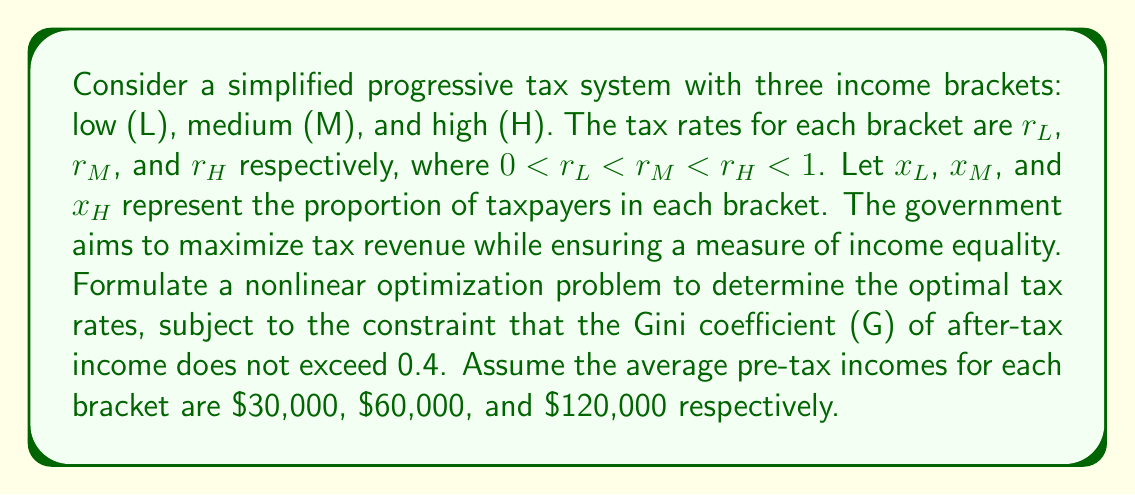Can you answer this question? To solve this problem, we'll follow these steps:

1) First, let's define our objective function. The government wants to maximize tax revenue:

   $$R = 30000r_Lx_L + 60000r_Mx_M + 120000r_Hx_H$$

2) Now, we need to formulate the constraint related to the Gini coefficient. The Gini coefficient for a three-level income distribution can be approximated as:

   $$G = \frac{x_L(y_M-y_L) + x_H(y_H-y_L) + x_M(y_H-y_M)}{2(x_Ly_L + x_My_M + x_Hy_H)}$$

   where $y_L$, $y_M$, and $y_H$ are the after-tax incomes for each bracket.

3) Calculate the after-tax incomes:
   
   $$y_L = 30000(1-r_L)$$
   $$y_M = 60000(1-r_M)$$
   $$y_H = 120000(1-r_H)$$

4) Substitute these into the Gini coefficient formula and set the constraint:

   $$\frac{x_L(60000(1-r_M)-30000(1-r_L)) + x_H(120000(1-r_H)-30000(1-r_L)) + x_M(120000(1-r_H)-60000(1-r_M))}{2(30000x_L(1-r_L) + 60000x_M(1-r_M) + 120000x_H(1-r_H))} \leq 0.4$$

5) We also need to add constraints for the tax rates:

   $$0 < r_L < r_M < r_H < 1$$

6) The proportions of taxpayers must sum to 1:

   $$x_L + x_M + x_H = 1$$

7) Now we can formulate the complete nonlinear optimization problem:

   Maximize:
   $$R = 30000r_Lx_L + 60000r_Mx_M + 120000r_Hx_H$$

   Subject to:
   $$\frac{x_L(60000(1-r_M)-30000(1-r_L)) + x_H(120000(1-r_H)-30000(1-r_L)) + x_M(120000(1-r_H)-60000(1-r_M))}{2(30000x_L(1-r_L) + 60000x_M(1-r_M) + 120000x_H(1-r_H))} \leq 0.4$$
   $$0 < r_L < r_M < r_H < 1$$
   $$x_L + x_M + x_H = 1$$
   $$x_L, x_M, x_H \geq 0$$

This nonlinear optimization problem can be solved using numerical methods such as interior point methods or sequential quadratic programming.
Answer: Maximize $R = 30000r_Lx_L + 60000r_Mx_M + 120000r_Hx_H$ subject to Gini coefficient $\leq 0.4$, $0 < r_L < r_M < r_H < 1$, $x_L + x_M + x_H = 1$, $x_L, x_M, x_H \geq 0$ 